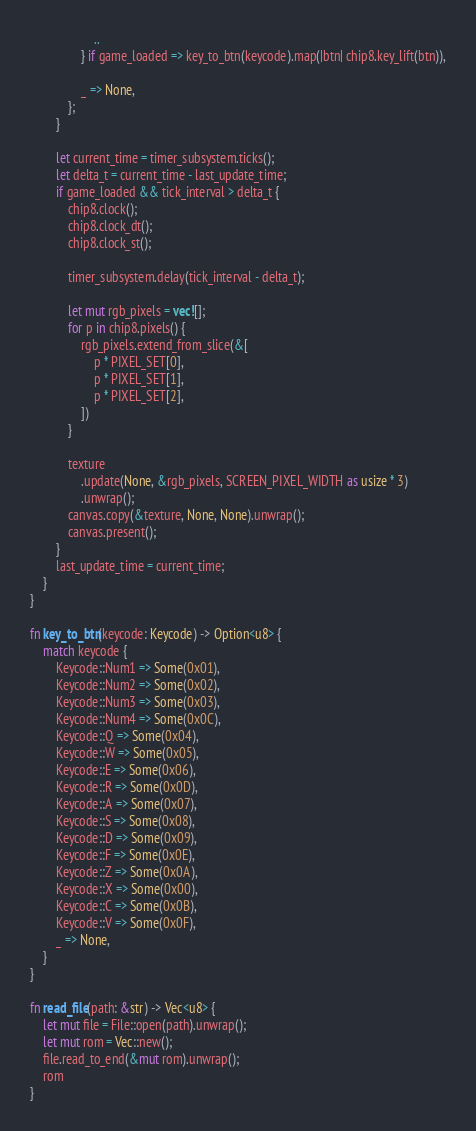<code> <loc_0><loc_0><loc_500><loc_500><_Rust_>                    ..
                } if game_loaded => key_to_btn(keycode).map(|btn| chip8.key_lift(btn)),

                _ => None,
            };
        }

        let current_time = timer_subsystem.ticks();
        let delta_t = current_time - last_update_time;
        if game_loaded && tick_interval > delta_t {
            chip8.clock();
            chip8.clock_dt();
            chip8.clock_st();

            timer_subsystem.delay(tick_interval - delta_t);

            let mut rgb_pixels = vec![];
            for p in chip8.pixels() {
                rgb_pixels.extend_from_slice(&[
                    p * PIXEL_SET[0],
                    p * PIXEL_SET[1],
                    p * PIXEL_SET[2],
                ])
            }

            texture
                .update(None, &rgb_pixels, SCREEN_PIXEL_WIDTH as usize * 3)
                .unwrap();
            canvas.copy(&texture, None, None).unwrap();
            canvas.present();
        }
        last_update_time = current_time;
    }
}

fn key_to_btn(keycode: Keycode) -> Option<u8> {
    match keycode {
        Keycode::Num1 => Some(0x01),
        Keycode::Num2 => Some(0x02),
        Keycode::Num3 => Some(0x03),
        Keycode::Num4 => Some(0x0C),
        Keycode::Q => Some(0x04),
        Keycode::W => Some(0x05),
        Keycode::E => Some(0x06),
        Keycode::R => Some(0x0D),
        Keycode::A => Some(0x07),
        Keycode::S => Some(0x08),
        Keycode::D => Some(0x09),
        Keycode::F => Some(0x0E),
        Keycode::Z => Some(0x0A),
        Keycode::X => Some(0x00),
        Keycode::C => Some(0x0B),
        Keycode::V => Some(0x0F),
        _ => None,
    }
}

fn read_file(path: &str) -> Vec<u8> {
    let mut file = File::open(path).unwrap();
    let mut rom = Vec::new();
    file.read_to_end(&mut rom).unwrap();
    rom
}
</code> 